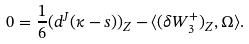Convert formula to latex. <formula><loc_0><loc_0><loc_500><loc_500>0 = \frac { 1 } { 6 } ( d ^ { J } ( \kappa - s ) ) _ { Z } - \langle ( \delta W _ { 3 } ^ { + } ) _ { Z } , \Omega \rangle .</formula> 